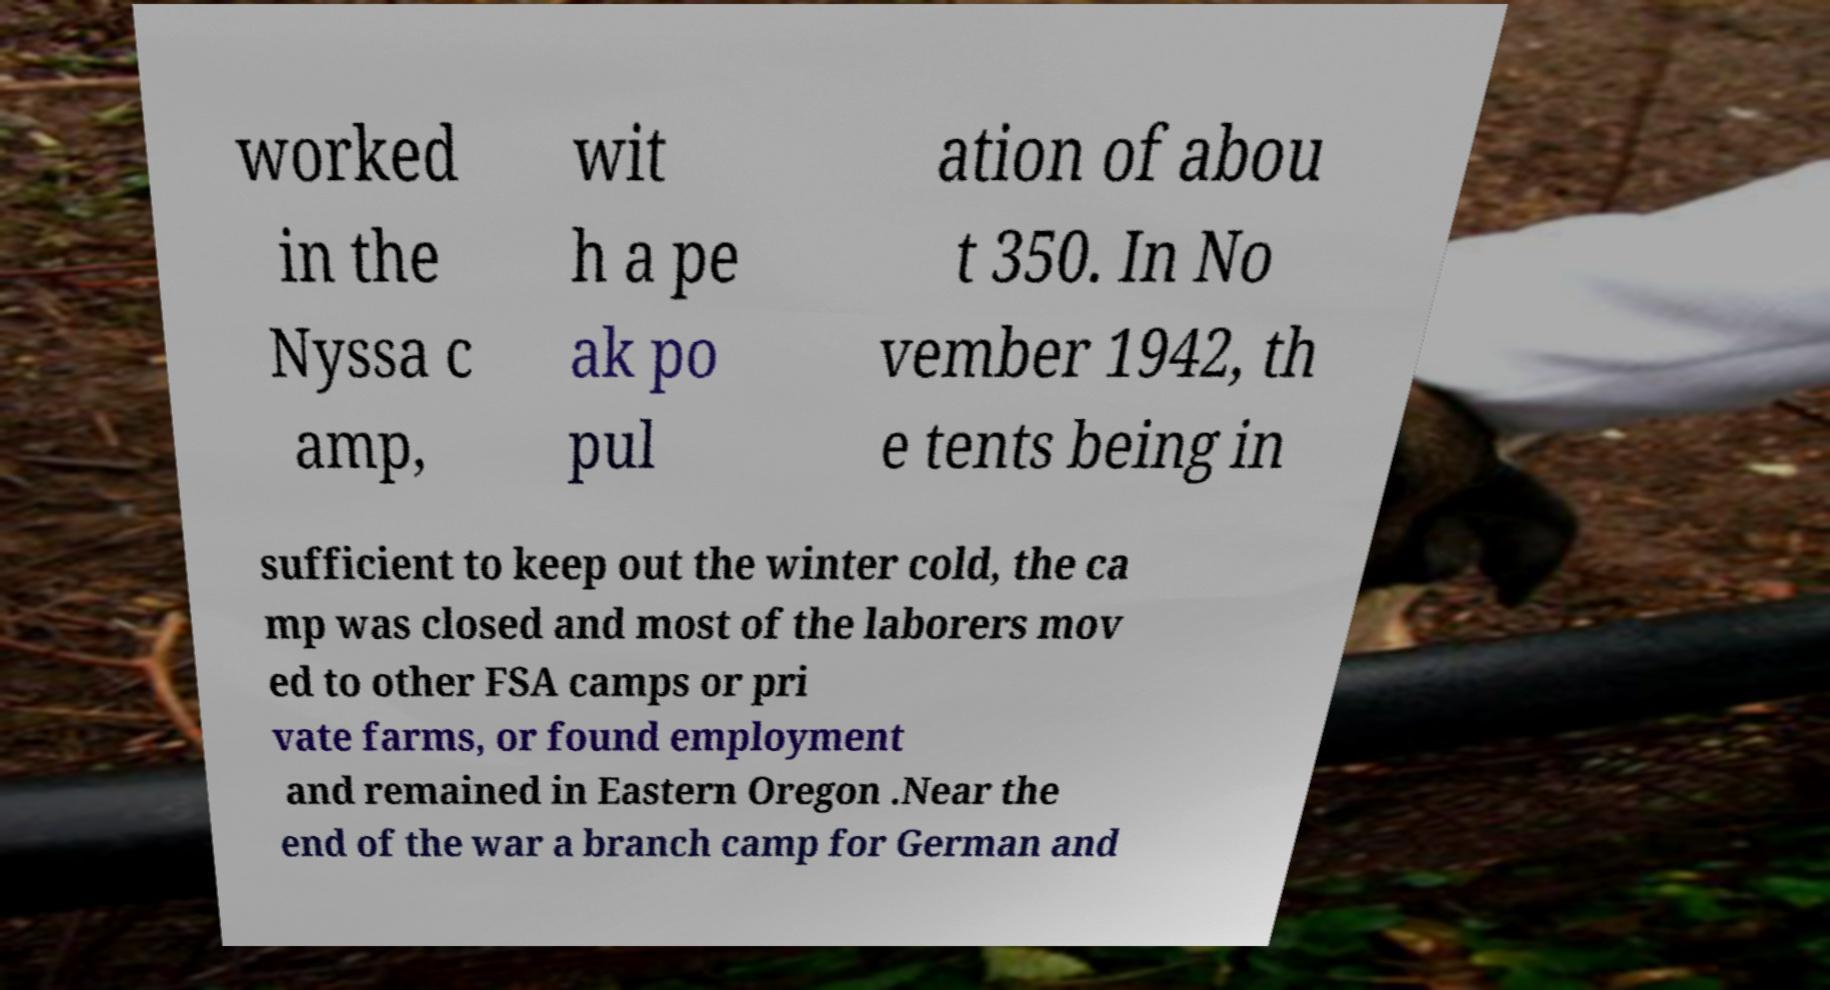Can you accurately transcribe the text from the provided image for me? worked in the Nyssa c amp, wit h a pe ak po pul ation of abou t 350. In No vember 1942, th e tents being in sufficient to keep out the winter cold, the ca mp was closed and most of the laborers mov ed to other FSA camps or pri vate farms, or found employment and remained in Eastern Oregon .Near the end of the war a branch camp for German and 